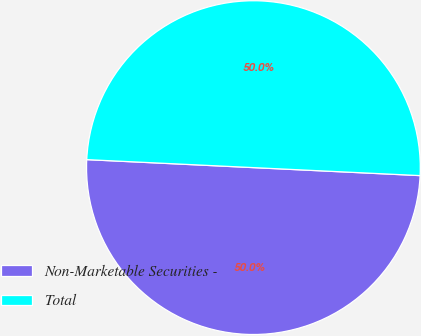Convert chart. <chart><loc_0><loc_0><loc_500><loc_500><pie_chart><fcel>Non-Marketable Securities -<fcel>Total<nl><fcel>50.0%<fcel>50.0%<nl></chart> 